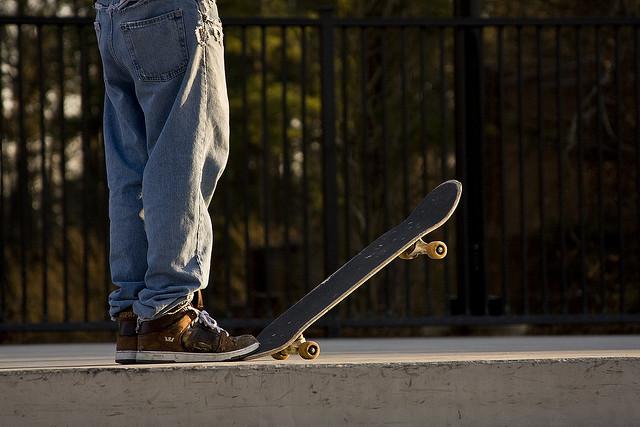Is the person wearing skateboarder shoes?
Give a very brief answer. Yes. What sport is depicted?
Quick response, please. Skateboarding. Are the skateboarders jeans baggy or tight?
Write a very short answer. Baggy. 